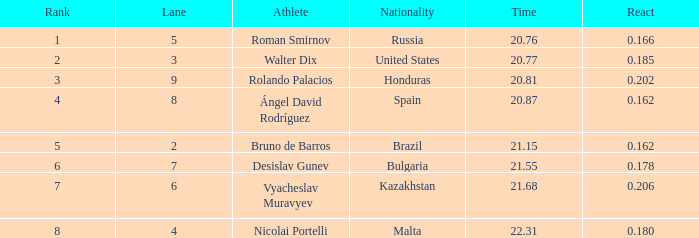55? None. 